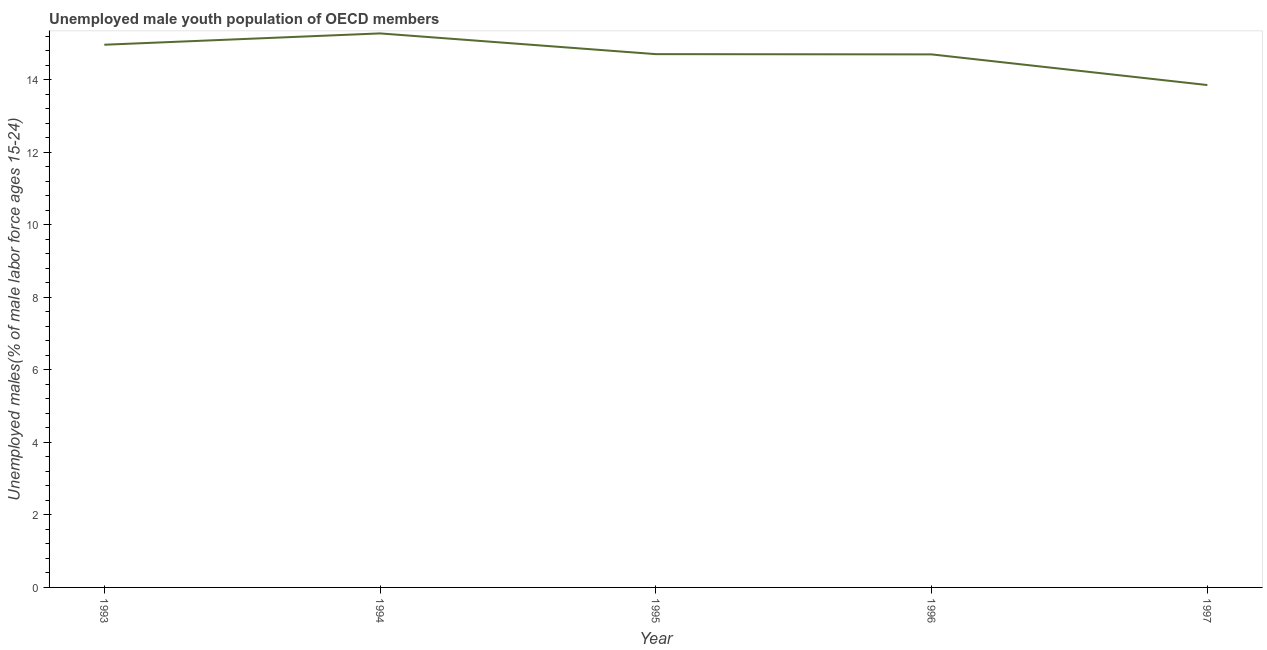What is the unemployed male youth in 1997?
Ensure brevity in your answer.  13.86. Across all years, what is the maximum unemployed male youth?
Keep it short and to the point. 15.29. Across all years, what is the minimum unemployed male youth?
Your response must be concise. 13.86. In which year was the unemployed male youth maximum?
Give a very brief answer. 1994. What is the sum of the unemployed male youth?
Your answer should be very brief. 73.54. What is the difference between the unemployed male youth in 1994 and 1996?
Provide a succinct answer. 0.58. What is the average unemployed male youth per year?
Your response must be concise. 14.71. What is the median unemployed male youth?
Offer a very short reply. 14.71. What is the ratio of the unemployed male youth in 1993 to that in 1997?
Ensure brevity in your answer.  1.08. What is the difference between the highest and the second highest unemployed male youth?
Make the answer very short. 0.31. What is the difference between the highest and the lowest unemployed male youth?
Offer a terse response. 1.42. In how many years, is the unemployed male youth greater than the average unemployed male youth taken over all years?
Offer a very short reply. 3. Are the values on the major ticks of Y-axis written in scientific E-notation?
Ensure brevity in your answer.  No. Does the graph contain any zero values?
Give a very brief answer. No. What is the title of the graph?
Make the answer very short. Unemployed male youth population of OECD members. What is the label or title of the Y-axis?
Provide a succinct answer. Unemployed males(% of male labor force ages 15-24). What is the Unemployed males(% of male labor force ages 15-24) of 1993?
Your answer should be compact. 14.97. What is the Unemployed males(% of male labor force ages 15-24) of 1994?
Provide a short and direct response. 15.29. What is the Unemployed males(% of male labor force ages 15-24) in 1995?
Ensure brevity in your answer.  14.71. What is the Unemployed males(% of male labor force ages 15-24) in 1996?
Your answer should be very brief. 14.71. What is the Unemployed males(% of male labor force ages 15-24) in 1997?
Make the answer very short. 13.86. What is the difference between the Unemployed males(% of male labor force ages 15-24) in 1993 and 1994?
Offer a very short reply. -0.31. What is the difference between the Unemployed males(% of male labor force ages 15-24) in 1993 and 1995?
Make the answer very short. 0.26. What is the difference between the Unemployed males(% of male labor force ages 15-24) in 1993 and 1996?
Make the answer very short. 0.27. What is the difference between the Unemployed males(% of male labor force ages 15-24) in 1993 and 1997?
Keep it short and to the point. 1.11. What is the difference between the Unemployed males(% of male labor force ages 15-24) in 1994 and 1995?
Ensure brevity in your answer.  0.57. What is the difference between the Unemployed males(% of male labor force ages 15-24) in 1994 and 1996?
Your response must be concise. 0.58. What is the difference between the Unemployed males(% of male labor force ages 15-24) in 1994 and 1997?
Make the answer very short. 1.42. What is the difference between the Unemployed males(% of male labor force ages 15-24) in 1995 and 1996?
Provide a short and direct response. 0.01. What is the difference between the Unemployed males(% of male labor force ages 15-24) in 1995 and 1997?
Your response must be concise. 0.85. What is the difference between the Unemployed males(% of male labor force ages 15-24) in 1996 and 1997?
Offer a terse response. 0.85. What is the ratio of the Unemployed males(% of male labor force ages 15-24) in 1993 to that in 1995?
Give a very brief answer. 1.02. What is the ratio of the Unemployed males(% of male labor force ages 15-24) in 1994 to that in 1995?
Make the answer very short. 1.04. What is the ratio of the Unemployed males(% of male labor force ages 15-24) in 1994 to that in 1996?
Offer a terse response. 1.04. What is the ratio of the Unemployed males(% of male labor force ages 15-24) in 1994 to that in 1997?
Provide a succinct answer. 1.1. What is the ratio of the Unemployed males(% of male labor force ages 15-24) in 1995 to that in 1996?
Make the answer very short. 1. What is the ratio of the Unemployed males(% of male labor force ages 15-24) in 1995 to that in 1997?
Offer a very short reply. 1.06. What is the ratio of the Unemployed males(% of male labor force ages 15-24) in 1996 to that in 1997?
Give a very brief answer. 1.06. 